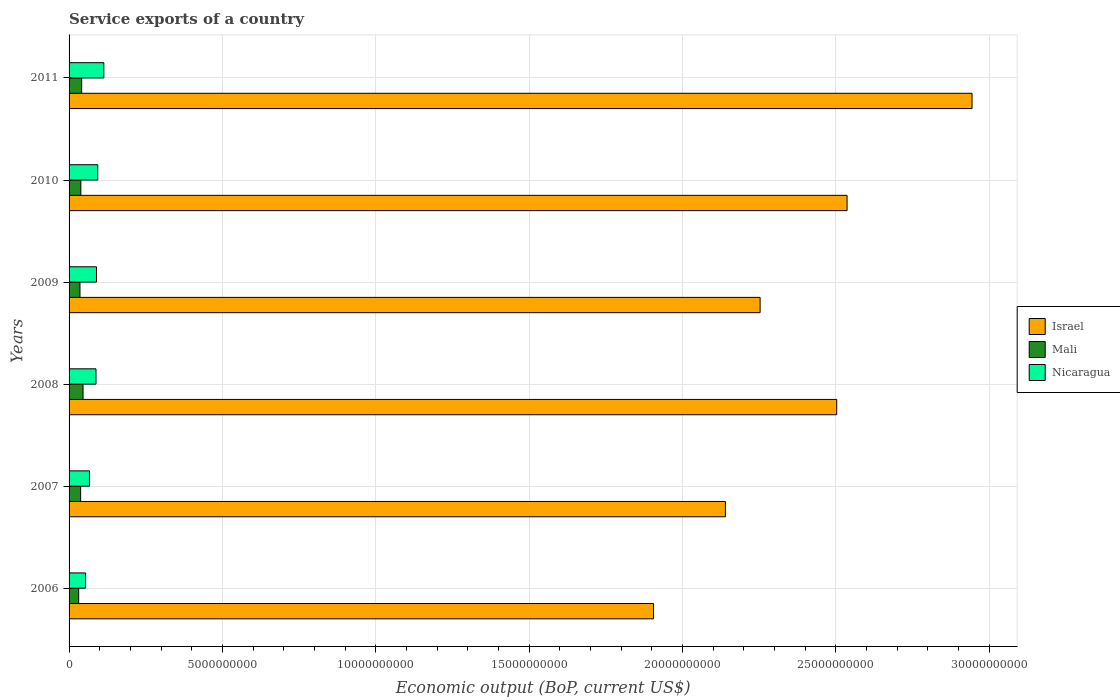How many different coloured bars are there?
Offer a terse response. 3. Are the number of bars per tick equal to the number of legend labels?
Your answer should be very brief. Yes. Are the number of bars on each tick of the Y-axis equal?
Offer a terse response. Yes. What is the label of the 6th group of bars from the top?
Make the answer very short. 2006. In how many cases, is the number of bars for a given year not equal to the number of legend labels?
Your response must be concise. 0. What is the service exports in Mali in 2009?
Provide a short and direct response. 3.56e+08. Across all years, what is the maximum service exports in Mali?
Your answer should be compact. 4.56e+08. Across all years, what is the minimum service exports in Israel?
Give a very brief answer. 1.91e+1. In which year was the service exports in Nicaragua minimum?
Your answer should be very brief. 2006. What is the total service exports in Mali in the graph?
Give a very brief answer. 2.30e+09. What is the difference between the service exports in Mali in 2010 and that in 2011?
Provide a succinct answer. -2.72e+07. What is the difference between the service exports in Israel in 2008 and the service exports in Nicaragua in 2007?
Keep it short and to the point. 2.44e+1. What is the average service exports in Nicaragua per year?
Offer a terse response. 8.41e+08. In the year 2009, what is the difference between the service exports in Mali and service exports in Nicaragua?
Provide a succinct answer. -5.38e+08. In how many years, is the service exports in Mali greater than 11000000000 US$?
Keep it short and to the point. 0. What is the ratio of the service exports in Mali in 2008 to that in 2010?
Provide a succinct answer. 1.19. Is the service exports in Nicaragua in 2007 less than that in 2008?
Keep it short and to the point. Yes. Is the difference between the service exports in Mali in 2006 and 2008 greater than the difference between the service exports in Nicaragua in 2006 and 2008?
Ensure brevity in your answer.  Yes. What is the difference between the highest and the second highest service exports in Nicaragua?
Provide a short and direct response. 1.98e+08. What is the difference between the highest and the lowest service exports in Israel?
Offer a terse response. 1.04e+1. Is the sum of the service exports in Mali in 2008 and 2010 greater than the maximum service exports in Israel across all years?
Give a very brief answer. No. What does the 2nd bar from the bottom in 2006 represents?
Provide a succinct answer. Mali. Are all the bars in the graph horizontal?
Your response must be concise. Yes. How many years are there in the graph?
Your answer should be very brief. 6. Are the values on the major ticks of X-axis written in scientific E-notation?
Keep it short and to the point. No. Does the graph contain grids?
Your answer should be compact. Yes. How are the legend labels stacked?
Your answer should be compact. Vertical. What is the title of the graph?
Give a very brief answer. Service exports of a country. Does "Low & middle income" appear as one of the legend labels in the graph?
Offer a very short reply. No. What is the label or title of the X-axis?
Your answer should be very brief. Economic output (BoP, current US$). What is the Economic output (BoP, current US$) in Israel in 2006?
Provide a succinct answer. 1.91e+1. What is the Economic output (BoP, current US$) in Mali in 2006?
Offer a very short reply. 3.13e+08. What is the Economic output (BoP, current US$) of Nicaragua in 2006?
Offer a terse response. 5.39e+08. What is the Economic output (BoP, current US$) in Israel in 2007?
Offer a very short reply. 2.14e+1. What is the Economic output (BoP, current US$) of Mali in 2007?
Give a very brief answer. 3.77e+08. What is the Economic output (BoP, current US$) in Nicaragua in 2007?
Make the answer very short. 6.66e+08. What is the Economic output (BoP, current US$) in Israel in 2008?
Provide a short and direct response. 2.50e+1. What is the Economic output (BoP, current US$) in Mali in 2008?
Ensure brevity in your answer.  4.56e+08. What is the Economic output (BoP, current US$) of Nicaragua in 2008?
Provide a succinct answer. 8.78e+08. What is the Economic output (BoP, current US$) in Israel in 2009?
Your answer should be compact. 2.25e+1. What is the Economic output (BoP, current US$) of Mali in 2009?
Provide a succinct answer. 3.56e+08. What is the Economic output (BoP, current US$) in Nicaragua in 2009?
Provide a succinct answer. 8.94e+08. What is the Economic output (BoP, current US$) in Israel in 2010?
Your answer should be compact. 2.54e+1. What is the Economic output (BoP, current US$) in Mali in 2010?
Ensure brevity in your answer.  3.84e+08. What is the Economic output (BoP, current US$) of Nicaragua in 2010?
Provide a succinct answer. 9.35e+08. What is the Economic output (BoP, current US$) in Israel in 2011?
Offer a very short reply. 2.94e+1. What is the Economic output (BoP, current US$) in Mali in 2011?
Your answer should be compact. 4.11e+08. What is the Economic output (BoP, current US$) of Nicaragua in 2011?
Keep it short and to the point. 1.13e+09. Across all years, what is the maximum Economic output (BoP, current US$) of Israel?
Keep it short and to the point. 2.94e+1. Across all years, what is the maximum Economic output (BoP, current US$) in Mali?
Provide a succinct answer. 4.56e+08. Across all years, what is the maximum Economic output (BoP, current US$) in Nicaragua?
Offer a very short reply. 1.13e+09. Across all years, what is the minimum Economic output (BoP, current US$) in Israel?
Make the answer very short. 1.91e+1. Across all years, what is the minimum Economic output (BoP, current US$) in Mali?
Offer a very short reply. 3.13e+08. Across all years, what is the minimum Economic output (BoP, current US$) of Nicaragua?
Your answer should be compact. 5.39e+08. What is the total Economic output (BoP, current US$) of Israel in the graph?
Make the answer very short. 1.43e+11. What is the total Economic output (BoP, current US$) in Mali in the graph?
Ensure brevity in your answer.  2.30e+09. What is the total Economic output (BoP, current US$) of Nicaragua in the graph?
Your response must be concise. 5.04e+09. What is the difference between the Economic output (BoP, current US$) of Israel in 2006 and that in 2007?
Provide a short and direct response. -2.34e+09. What is the difference between the Economic output (BoP, current US$) in Mali in 2006 and that in 2007?
Offer a very short reply. -6.38e+07. What is the difference between the Economic output (BoP, current US$) in Nicaragua in 2006 and that in 2007?
Make the answer very short. -1.27e+08. What is the difference between the Economic output (BoP, current US$) in Israel in 2006 and that in 2008?
Your response must be concise. -5.97e+09. What is the difference between the Economic output (BoP, current US$) in Mali in 2006 and that in 2008?
Your answer should be very brief. -1.42e+08. What is the difference between the Economic output (BoP, current US$) of Nicaragua in 2006 and that in 2008?
Your response must be concise. -3.39e+08. What is the difference between the Economic output (BoP, current US$) of Israel in 2006 and that in 2009?
Give a very brief answer. -3.48e+09. What is the difference between the Economic output (BoP, current US$) of Mali in 2006 and that in 2009?
Offer a very short reply. -4.24e+07. What is the difference between the Economic output (BoP, current US$) in Nicaragua in 2006 and that in 2009?
Your answer should be compact. -3.55e+08. What is the difference between the Economic output (BoP, current US$) of Israel in 2006 and that in 2010?
Your response must be concise. -6.31e+09. What is the difference between the Economic output (BoP, current US$) of Mali in 2006 and that in 2010?
Give a very brief answer. -7.03e+07. What is the difference between the Economic output (BoP, current US$) in Nicaragua in 2006 and that in 2010?
Make the answer very short. -3.97e+08. What is the difference between the Economic output (BoP, current US$) in Israel in 2006 and that in 2011?
Offer a terse response. -1.04e+1. What is the difference between the Economic output (BoP, current US$) in Mali in 2006 and that in 2011?
Give a very brief answer. -9.75e+07. What is the difference between the Economic output (BoP, current US$) of Nicaragua in 2006 and that in 2011?
Your answer should be very brief. -5.95e+08. What is the difference between the Economic output (BoP, current US$) of Israel in 2007 and that in 2008?
Provide a short and direct response. -3.63e+09. What is the difference between the Economic output (BoP, current US$) in Mali in 2007 and that in 2008?
Ensure brevity in your answer.  -7.86e+07. What is the difference between the Economic output (BoP, current US$) in Nicaragua in 2007 and that in 2008?
Make the answer very short. -2.12e+08. What is the difference between the Economic output (BoP, current US$) in Israel in 2007 and that in 2009?
Provide a succinct answer. -1.13e+09. What is the difference between the Economic output (BoP, current US$) of Mali in 2007 and that in 2009?
Ensure brevity in your answer.  2.14e+07. What is the difference between the Economic output (BoP, current US$) in Nicaragua in 2007 and that in 2009?
Keep it short and to the point. -2.28e+08. What is the difference between the Economic output (BoP, current US$) in Israel in 2007 and that in 2010?
Offer a terse response. -3.97e+09. What is the difference between the Economic output (BoP, current US$) in Mali in 2007 and that in 2010?
Provide a short and direct response. -6.52e+06. What is the difference between the Economic output (BoP, current US$) of Nicaragua in 2007 and that in 2010?
Provide a succinct answer. -2.70e+08. What is the difference between the Economic output (BoP, current US$) of Israel in 2007 and that in 2011?
Ensure brevity in your answer.  -8.04e+09. What is the difference between the Economic output (BoP, current US$) of Mali in 2007 and that in 2011?
Ensure brevity in your answer.  -3.37e+07. What is the difference between the Economic output (BoP, current US$) of Nicaragua in 2007 and that in 2011?
Give a very brief answer. -4.68e+08. What is the difference between the Economic output (BoP, current US$) of Israel in 2008 and that in 2009?
Your response must be concise. 2.50e+09. What is the difference between the Economic output (BoP, current US$) in Mali in 2008 and that in 2009?
Your answer should be compact. 1.00e+08. What is the difference between the Economic output (BoP, current US$) in Nicaragua in 2008 and that in 2009?
Provide a succinct answer. -1.61e+07. What is the difference between the Economic output (BoP, current US$) of Israel in 2008 and that in 2010?
Keep it short and to the point. -3.39e+08. What is the difference between the Economic output (BoP, current US$) of Mali in 2008 and that in 2010?
Give a very brief answer. 7.21e+07. What is the difference between the Economic output (BoP, current US$) of Nicaragua in 2008 and that in 2010?
Keep it short and to the point. -5.74e+07. What is the difference between the Economic output (BoP, current US$) in Israel in 2008 and that in 2011?
Make the answer very short. -4.41e+09. What is the difference between the Economic output (BoP, current US$) in Mali in 2008 and that in 2011?
Ensure brevity in your answer.  4.49e+07. What is the difference between the Economic output (BoP, current US$) of Nicaragua in 2008 and that in 2011?
Your answer should be very brief. -2.56e+08. What is the difference between the Economic output (BoP, current US$) in Israel in 2009 and that in 2010?
Provide a short and direct response. -2.84e+09. What is the difference between the Economic output (BoP, current US$) of Mali in 2009 and that in 2010?
Your answer should be very brief. -2.79e+07. What is the difference between the Economic output (BoP, current US$) in Nicaragua in 2009 and that in 2010?
Provide a succinct answer. -4.13e+07. What is the difference between the Economic output (BoP, current US$) in Israel in 2009 and that in 2011?
Give a very brief answer. -6.91e+09. What is the difference between the Economic output (BoP, current US$) in Mali in 2009 and that in 2011?
Offer a terse response. -5.51e+07. What is the difference between the Economic output (BoP, current US$) of Nicaragua in 2009 and that in 2011?
Offer a very short reply. -2.40e+08. What is the difference between the Economic output (BoP, current US$) of Israel in 2010 and that in 2011?
Offer a very short reply. -4.07e+09. What is the difference between the Economic output (BoP, current US$) of Mali in 2010 and that in 2011?
Give a very brief answer. -2.72e+07. What is the difference between the Economic output (BoP, current US$) in Nicaragua in 2010 and that in 2011?
Keep it short and to the point. -1.98e+08. What is the difference between the Economic output (BoP, current US$) of Israel in 2006 and the Economic output (BoP, current US$) of Mali in 2007?
Make the answer very short. 1.87e+1. What is the difference between the Economic output (BoP, current US$) in Israel in 2006 and the Economic output (BoP, current US$) in Nicaragua in 2007?
Give a very brief answer. 1.84e+1. What is the difference between the Economic output (BoP, current US$) in Mali in 2006 and the Economic output (BoP, current US$) in Nicaragua in 2007?
Give a very brief answer. -3.52e+08. What is the difference between the Economic output (BoP, current US$) of Israel in 2006 and the Economic output (BoP, current US$) of Mali in 2008?
Provide a succinct answer. 1.86e+1. What is the difference between the Economic output (BoP, current US$) of Israel in 2006 and the Economic output (BoP, current US$) of Nicaragua in 2008?
Provide a short and direct response. 1.82e+1. What is the difference between the Economic output (BoP, current US$) in Mali in 2006 and the Economic output (BoP, current US$) in Nicaragua in 2008?
Offer a terse response. -5.65e+08. What is the difference between the Economic output (BoP, current US$) of Israel in 2006 and the Economic output (BoP, current US$) of Mali in 2009?
Provide a short and direct response. 1.87e+1. What is the difference between the Economic output (BoP, current US$) of Israel in 2006 and the Economic output (BoP, current US$) of Nicaragua in 2009?
Make the answer very short. 1.82e+1. What is the difference between the Economic output (BoP, current US$) of Mali in 2006 and the Economic output (BoP, current US$) of Nicaragua in 2009?
Your answer should be very brief. -5.81e+08. What is the difference between the Economic output (BoP, current US$) of Israel in 2006 and the Economic output (BoP, current US$) of Mali in 2010?
Keep it short and to the point. 1.87e+1. What is the difference between the Economic output (BoP, current US$) in Israel in 2006 and the Economic output (BoP, current US$) in Nicaragua in 2010?
Your answer should be very brief. 1.81e+1. What is the difference between the Economic output (BoP, current US$) of Mali in 2006 and the Economic output (BoP, current US$) of Nicaragua in 2010?
Your answer should be very brief. -6.22e+08. What is the difference between the Economic output (BoP, current US$) in Israel in 2006 and the Economic output (BoP, current US$) in Mali in 2011?
Your answer should be very brief. 1.86e+1. What is the difference between the Economic output (BoP, current US$) of Israel in 2006 and the Economic output (BoP, current US$) of Nicaragua in 2011?
Your answer should be very brief. 1.79e+1. What is the difference between the Economic output (BoP, current US$) in Mali in 2006 and the Economic output (BoP, current US$) in Nicaragua in 2011?
Your answer should be compact. -8.20e+08. What is the difference between the Economic output (BoP, current US$) of Israel in 2007 and the Economic output (BoP, current US$) of Mali in 2008?
Provide a succinct answer. 2.09e+1. What is the difference between the Economic output (BoP, current US$) in Israel in 2007 and the Economic output (BoP, current US$) in Nicaragua in 2008?
Make the answer very short. 2.05e+1. What is the difference between the Economic output (BoP, current US$) in Mali in 2007 and the Economic output (BoP, current US$) in Nicaragua in 2008?
Your response must be concise. -5.01e+08. What is the difference between the Economic output (BoP, current US$) in Israel in 2007 and the Economic output (BoP, current US$) in Mali in 2009?
Your answer should be very brief. 2.10e+1. What is the difference between the Economic output (BoP, current US$) of Israel in 2007 and the Economic output (BoP, current US$) of Nicaragua in 2009?
Your answer should be compact. 2.05e+1. What is the difference between the Economic output (BoP, current US$) in Mali in 2007 and the Economic output (BoP, current US$) in Nicaragua in 2009?
Your answer should be compact. -5.17e+08. What is the difference between the Economic output (BoP, current US$) of Israel in 2007 and the Economic output (BoP, current US$) of Mali in 2010?
Provide a short and direct response. 2.10e+1. What is the difference between the Economic output (BoP, current US$) in Israel in 2007 and the Economic output (BoP, current US$) in Nicaragua in 2010?
Your answer should be compact. 2.05e+1. What is the difference between the Economic output (BoP, current US$) in Mali in 2007 and the Economic output (BoP, current US$) in Nicaragua in 2010?
Your answer should be very brief. -5.58e+08. What is the difference between the Economic output (BoP, current US$) of Israel in 2007 and the Economic output (BoP, current US$) of Mali in 2011?
Provide a short and direct response. 2.10e+1. What is the difference between the Economic output (BoP, current US$) of Israel in 2007 and the Economic output (BoP, current US$) of Nicaragua in 2011?
Keep it short and to the point. 2.03e+1. What is the difference between the Economic output (BoP, current US$) in Mali in 2007 and the Economic output (BoP, current US$) in Nicaragua in 2011?
Your answer should be very brief. -7.56e+08. What is the difference between the Economic output (BoP, current US$) of Israel in 2008 and the Economic output (BoP, current US$) of Mali in 2009?
Your answer should be very brief. 2.47e+1. What is the difference between the Economic output (BoP, current US$) of Israel in 2008 and the Economic output (BoP, current US$) of Nicaragua in 2009?
Offer a terse response. 2.41e+1. What is the difference between the Economic output (BoP, current US$) in Mali in 2008 and the Economic output (BoP, current US$) in Nicaragua in 2009?
Ensure brevity in your answer.  -4.38e+08. What is the difference between the Economic output (BoP, current US$) of Israel in 2008 and the Economic output (BoP, current US$) of Mali in 2010?
Offer a very short reply. 2.46e+1. What is the difference between the Economic output (BoP, current US$) of Israel in 2008 and the Economic output (BoP, current US$) of Nicaragua in 2010?
Your response must be concise. 2.41e+1. What is the difference between the Economic output (BoP, current US$) in Mali in 2008 and the Economic output (BoP, current US$) in Nicaragua in 2010?
Offer a terse response. -4.80e+08. What is the difference between the Economic output (BoP, current US$) in Israel in 2008 and the Economic output (BoP, current US$) in Mali in 2011?
Keep it short and to the point. 2.46e+1. What is the difference between the Economic output (BoP, current US$) in Israel in 2008 and the Economic output (BoP, current US$) in Nicaragua in 2011?
Your answer should be very brief. 2.39e+1. What is the difference between the Economic output (BoP, current US$) in Mali in 2008 and the Economic output (BoP, current US$) in Nicaragua in 2011?
Your response must be concise. -6.78e+08. What is the difference between the Economic output (BoP, current US$) in Israel in 2009 and the Economic output (BoP, current US$) in Mali in 2010?
Give a very brief answer. 2.22e+1. What is the difference between the Economic output (BoP, current US$) in Israel in 2009 and the Economic output (BoP, current US$) in Nicaragua in 2010?
Give a very brief answer. 2.16e+1. What is the difference between the Economic output (BoP, current US$) of Mali in 2009 and the Economic output (BoP, current US$) of Nicaragua in 2010?
Offer a terse response. -5.80e+08. What is the difference between the Economic output (BoP, current US$) in Israel in 2009 and the Economic output (BoP, current US$) in Mali in 2011?
Provide a succinct answer. 2.21e+1. What is the difference between the Economic output (BoP, current US$) of Israel in 2009 and the Economic output (BoP, current US$) of Nicaragua in 2011?
Ensure brevity in your answer.  2.14e+1. What is the difference between the Economic output (BoP, current US$) in Mali in 2009 and the Economic output (BoP, current US$) in Nicaragua in 2011?
Offer a very short reply. -7.78e+08. What is the difference between the Economic output (BoP, current US$) of Israel in 2010 and the Economic output (BoP, current US$) of Mali in 2011?
Provide a short and direct response. 2.50e+1. What is the difference between the Economic output (BoP, current US$) of Israel in 2010 and the Economic output (BoP, current US$) of Nicaragua in 2011?
Offer a very short reply. 2.42e+1. What is the difference between the Economic output (BoP, current US$) of Mali in 2010 and the Economic output (BoP, current US$) of Nicaragua in 2011?
Your response must be concise. -7.50e+08. What is the average Economic output (BoP, current US$) in Israel per year?
Keep it short and to the point. 2.38e+1. What is the average Economic output (BoP, current US$) of Mali per year?
Your answer should be very brief. 3.83e+08. What is the average Economic output (BoP, current US$) in Nicaragua per year?
Ensure brevity in your answer.  8.41e+08. In the year 2006, what is the difference between the Economic output (BoP, current US$) in Israel and Economic output (BoP, current US$) in Mali?
Give a very brief answer. 1.87e+1. In the year 2006, what is the difference between the Economic output (BoP, current US$) in Israel and Economic output (BoP, current US$) in Nicaragua?
Your answer should be very brief. 1.85e+1. In the year 2006, what is the difference between the Economic output (BoP, current US$) of Mali and Economic output (BoP, current US$) of Nicaragua?
Make the answer very short. -2.25e+08. In the year 2007, what is the difference between the Economic output (BoP, current US$) of Israel and Economic output (BoP, current US$) of Mali?
Offer a very short reply. 2.10e+1. In the year 2007, what is the difference between the Economic output (BoP, current US$) in Israel and Economic output (BoP, current US$) in Nicaragua?
Keep it short and to the point. 2.07e+1. In the year 2007, what is the difference between the Economic output (BoP, current US$) of Mali and Economic output (BoP, current US$) of Nicaragua?
Ensure brevity in your answer.  -2.88e+08. In the year 2008, what is the difference between the Economic output (BoP, current US$) of Israel and Economic output (BoP, current US$) of Mali?
Offer a very short reply. 2.46e+1. In the year 2008, what is the difference between the Economic output (BoP, current US$) in Israel and Economic output (BoP, current US$) in Nicaragua?
Offer a very short reply. 2.42e+1. In the year 2008, what is the difference between the Economic output (BoP, current US$) in Mali and Economic output (BoP, current US$) in Nicaragua?
Provide a succinct answer. -4.22e+08. In the year 2009, what is the difference between the Economic output (BoP, current US$) in Israel and Economic output (BoP, current US$) in Mali?
Provide a succinct answer. 2.22e+1. In the year 2009, what is the difference between the Economic output (BoP, current US$) of Israel and Economic output (BoP, current US$) of Nicaragua?
Keep it short and to the point. 2.16e+1. In the year 2009, what is the difference between the Economic output (BoP, current US$) of Mali and Economic output (BoP, current US$) of Nicaragua?
Offer a very short reply. -5.38e+08. In the year 2010, what is the difference between the Economic output (BoP, current US$) in Israel and Economic output (BoP, current US$) in Mali?
Ensure brevity in your answer.  2.50e+1. In the year 2010, what is the difference between the Economic output (BoP, current US$) in Israel and Economic output (BoP, current US$) in Nicaragua?
Offer a terse response. 2.44e+1. In the year 2010, what is the difference between the Economic output (BoP, current US$) of Mali and Economic output (BoP, current US$) of Nicaragua?
Provide a succinct answer. -5.52e+08. In the year 2011, what is the difference between the Economic output (BoP, current US$) of Israel and Economic output (BoP, current US$) of Mali?
Ensure brevity in your answer.  2.90e+1. In the year 2011, what is the difference between the Economic output (BoP, current US$) in Israel and Economic output (BoP, current US$) in Nicaragua?
Keep it short and to the point. 2.83e+1. In the year 2011, what is the difference between the Economic output (BoP, current US$) in Mali and Economic output (BoP, current US$) in Nicaragua?
Give a very brief answer. -7.23e+08. What is the ratio of the Economic output (BoP, current US$) of Israel in 2006 to that in 2007?
Keep it short and to the point. 0.89. What is the ratio of the Economic output (BoP, current US$) of Mali in 2006 to that in 2007?
Provide a succinct answer. 0.83. What is the ratio of the Economic output (BoP, current US$) in Nicaragua in 2006 to that in 2007?
Offer a very short reply. 0.81. What is the ratio of the Economic output (BoP, current US$) of Israel in 2006 to that in 2008?
Keep it short and to the point. 0.76. What is the ratio of the Economic output (BoP, current US$) in Mali in 2006 to that in 2008?
Your answer should be very brief. 0.69. What is the ratio of the Economic output (BoP, current US$) of Nicaragua in 2006 to that in 2008?
Your answer should be very brief. 0.61. What is the ratio of the Economic output (BoP, current US$) of Israel in 2006 to that in 2009?
Your response must be concise. 0.85. What is the ratio of the Economic output (BoP, current US$) in Mali in 2006 to that in 2009?
Make the answer very short. 0.88. What is the ratio of the Economic output (BoP, current US$) of Nicaragua in 2006 to that in 2009?
Your answer should be very brief. 0.6. What is the ratio of the Economic output (BoP, current US$) of Israel in 2006 to that in 2010?
Offer a terse response. 0.75. What is the ratio of the Economic output (BoP, current US$) in Mali in 2006 to that in 2010?
Your response must be concise. 0.82. What is the ratio of the Economic output (BoP, current US$) of Nicaragua in 2006 to that in 2010?
Provide a succinct answer. 0.58. What is the ratio of the Economic output (BoP, current US$) in Israel in 2006 to that in 2011?
Your answer should be very brief. 0.65. What is the ratio of the Economic output (BoP, current US$) of Mali in 2006 to that in 2011?
Your response must be concise. 0.76. What is the ratio of the Economic output (BoP, current US$) in Nicaragua in 2006 to that in 2011?
Give a very brief answer. 0.48. What is the ratio of the Economic output (BoP, current US$) of Israel in 2007 to that in 2008?
Your response must be concise. 0.85. What is the ratio of the Economic output (BoP, current US$) in Mali in 2007 to that in 2008?
Your answer should be very brief. 0.83. What is the ratio of the Economic output (BoP, current US$) in Nicaragua in 2007 to that in 2008?
Your answer should be compact. 0.76. What is the ratio of the Economic output (BoP, current US$) of Israel in 2007 to that in 2009?
Provide a short and direct response. 0.95. What is the ratio of the Economic output (BoP, current US$) in Mali in 2007 to that in 2009?
Ensure brevity in your answer.  1.06. What is the ratio of the Economic output (BoP, current US$) of Nicaragua in 2007 to that in 2009?
Your answer should be compact. 0.74. What is the ratio of the Economic output (BoP, current US$) in Israel in 2007 to that in 2010?
Ensure brevity in your answer.  0.84. What is the ratio of the Economic output (BoP, current US$) in Mali in 2007 to that in 2010?
Your answer should be very brief. 0.98. What is the ratio of the Economic output (BoP, current US$) of Nicaragua in 2007 to that in 2010?
Your answer should be very brief. 0.71. What is the ratio of the Economic output (BoP, current US$) of Israel in 2007 to that in 2011?
Give a very brief answer. 0.73. What is the ratio of the Economic output (BoP, current US$) in Mali in 2007 to that in 2011?
Offer a very short reply. 0.92. What is the ratio of the Economic output (BoP, current US$) in Nicaragua in 2007 to that in 2011?
Provide a short and direct response. 0.59. What is the ratio of the Economic output (BoP, current US$) in Israel in 2008 to that in 2009?
Your answer should be compact. 1.11. What is the ratio of the Economic output (BoP, current US$) in Mali in 2008 to that in 2009?
Your response must be concise. 1.28. What is the ratio of the Economic output (BoP, current US$) in Nicaragua in 2008 to that in 2009?
Provide a succinct answer. 0.98. What is the ratio of the Economic output (BoP, current US$) of Israel in 2008 to that in 2010?
Offer a terse response. 0.99. What is the ratio of the Economic output (BoP, current US$) in Mali in 2008 to that in 2010?
Your response must be concise. 1.19. What is the ratio of the Economic output (BoP, current US$) in Nicaragua in 2008 to that in 2010?
Provide a short and direct response. 0.94. What is the ratio of the Economic output (BoP, current US$) in Israel in 2008 to that in 2011?
Ensure brevity in your answer.  0.85. What is the ratio of the Economic output (BoP, current US$) of Mali in 2008 to that in 2011?
Provide a short and direct response. 1.11. What is the ratio of the Economic output (BoP, current US$) in Nicaragua in 2008 to that in 2011?
Your response must be concise. 0.77. What is the ratio of the Economic output (BoP, current US$) in Israel in 2009 to that in 2010?
Offer a terse response. 0.89. What is the ratio of the Economic output (BoP, current US$) in Mali in 2009 to that in 2010?
Keep it short and to the point. 0.93. What is the ratio of the Economic output (BoP, current US$) of Nicaragua in 2009 to that in 2010?
Provide a short and direct response. 0.96. What is the ratio of the Economic output (BoP, current US$) in Israel in 2009 to that in 2011?
Ensure brevity in your answer.  0.77. What is the ratio of the Economic output (BoP, current US$) of Mali in 2009 to that in 2011?
Your response must be concise. 0.87. What is the ratio of the Economic output (BoP, current US$) of Nicaragua in 2009 to that in 2011?
Your answer should be very brief. 0.79. What is the ratio of the Economic output (BoP, current US$) of Israel in 2010 to that in 2011?
Your answer should be compact. 0.86. What is the ratio of the Economic output (BoP, current US$) of Mali in 2010 to that in 2011?
Your response must be concise. 0.93. What is the ratio of the Economic output (BoP, current US$) of Nicaragua in 2010 to that in 2011?
Your response must be concise. 0.83. What is the difference between the highest and the second highest Economic output (BoP, current US$) in Israel?
Keep it short and to the point. 4.07e+09. What is the difference between the highest and the second highest Economic output (BoP, current US$) in Mali?
Provide a short and direct response. 4.49e+07. What is the difference between the highest and the second highest Economic output (BoP, current US$) of Nicaragua?
Offer a very short reply. 1.98e+08. What is the difference between the highest and the lowest Economic output (BoP, current US$) of Israel?
Keep it short and to the point. 1.04e+1. What is the difference between the highest and the lowest Economic output (BoP, current US$) in Mali?
Keep it short and to the point. 1.42e+08. What is the difference between the highest and the lowest Economic output (BoP, current US$) in Nicaragua?
Ensure brevity in your answer.  5.95e+08. 